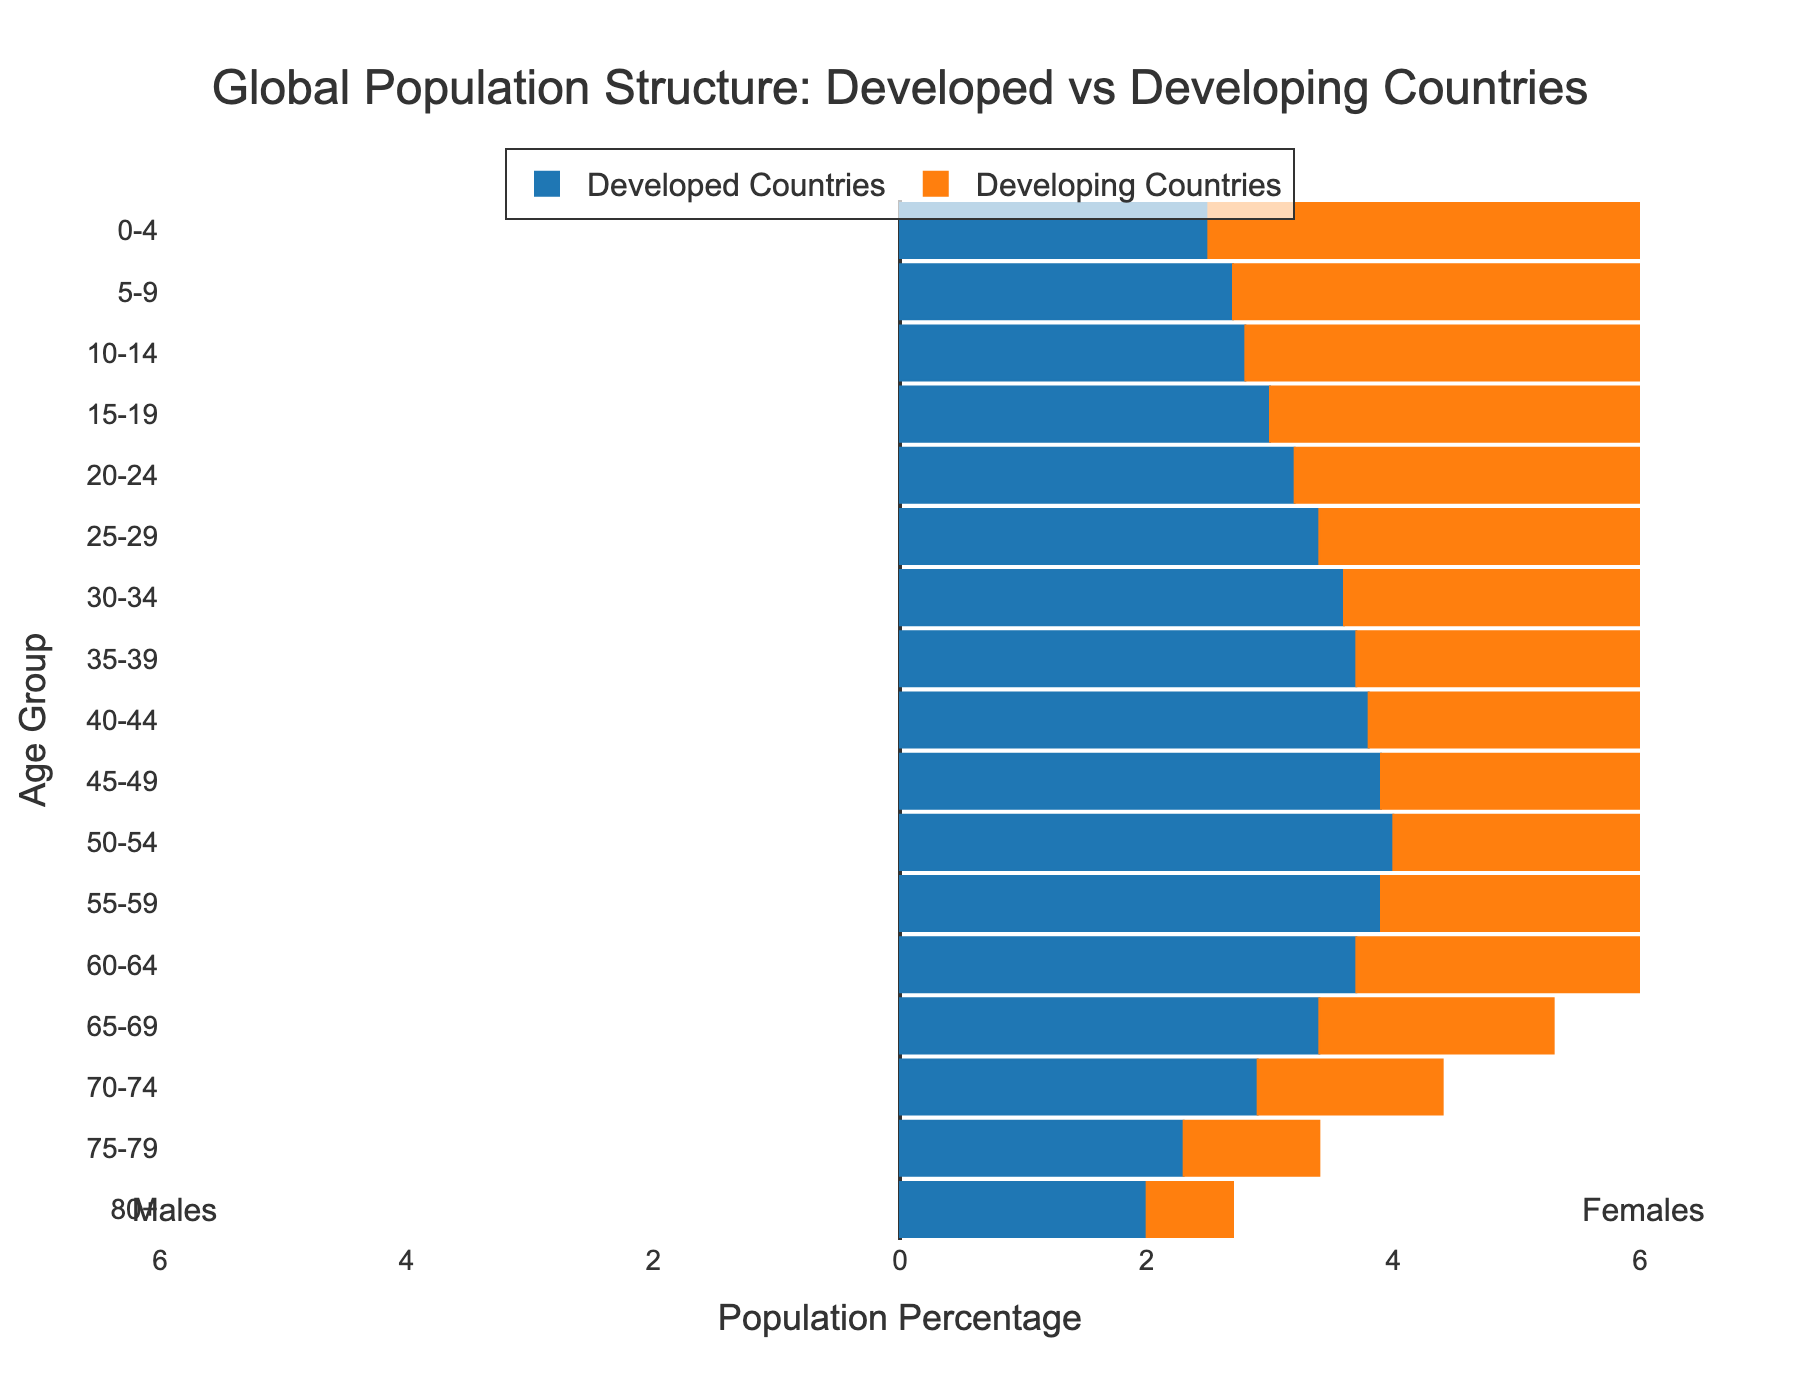What is the title of the figure? The title of the figure is displayed at the top. It reads "Global Population Structure: Developed vs Developing Countries" based on the given code.
Answer: Global Population Structure: Developed vs Developing Countries Which age group has the highest population percentage in developing countries? The highest population percentage for developing countries is found by looking at the longest orange bar, which corresponds to the age group "0-4" with 5.1%.
Answer: 0-4 How does the population percentage of age group 25-29 compare between developed and developing countries? We compare the length of the bars for age group 25-29. The developed countries have a percentage of -3.4% and developing countries have 4.1%. Developing countries have a higher percentage.
Answer: Developing countries have a higher percentage What is the approximate sum of the population percentages for age group 65-69 through 80+ in developed countries? Add the absolute values of the population percentages for developed countries in the age groups 65-69 through 80+. Therefore, 3.4% + 2.9% + 2.3% + 2.0% equals around 10.6%.
Answer: 10.6% Which country category has a larger elderly population, and what might that indicate about the healthcare or lifespan? (70+ years) Compare the population percentages for age groups 70-74, 75-79, and 80+ for both country categories. Developed countries have higher percentages. This suggests better healthcare and longer lifespans in developed countries.
Answer: Developed countries What is the trend in population percentages from age group 0-4 to age group 80+ in developing countries? Observe the orange bars in the figure. The population percentages generally decrease from age group 0-4 (5.1%) to age group 80+ (0.7%), showing a declining trend as age increases.
Answer: Decreasing trend What is the overall difference in population percentages between developed and developing countries for the age group 50-54? The population percentage for developed countries is -4.0% and for developing countries is 3.0%. The overall difference is
Answer: 7.0% In which age group does the population percentage difference between developed and developing countries reach the lowest? Examine the bar lengths. The smallest difference is in age group 80+ where the difference is -2.0% to 0.7%, or 2.7%.
Answer: 80+ How does the male population in the 30-34 age group in developed countries compare to the female population in the same age group? For developed countries, the percentage is -3.6% (males) for 30-34 age groups. Since this figure separately shows males and females, the question isn’t directly answerable from the data provided as it doesn’t split percentages by gender within each category.
Answer: Not Directly Answerable What is the general shape of the population pyramid for developed countries, and what does it suggest about their population growth? The bars for developed countries are wide in the middle and narrow at the bottom, indicating low birth rates and an aging population. This suggests a slow or negative population growth.
Answer: Slow or negative growth 